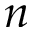<formula> <loc_0><loc_0><loc_500><loc_500>n</formula> 